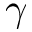Convert formula to latex. <formula><loc_0><loc_0><loc_500><loc_500>\gamma</formula> 